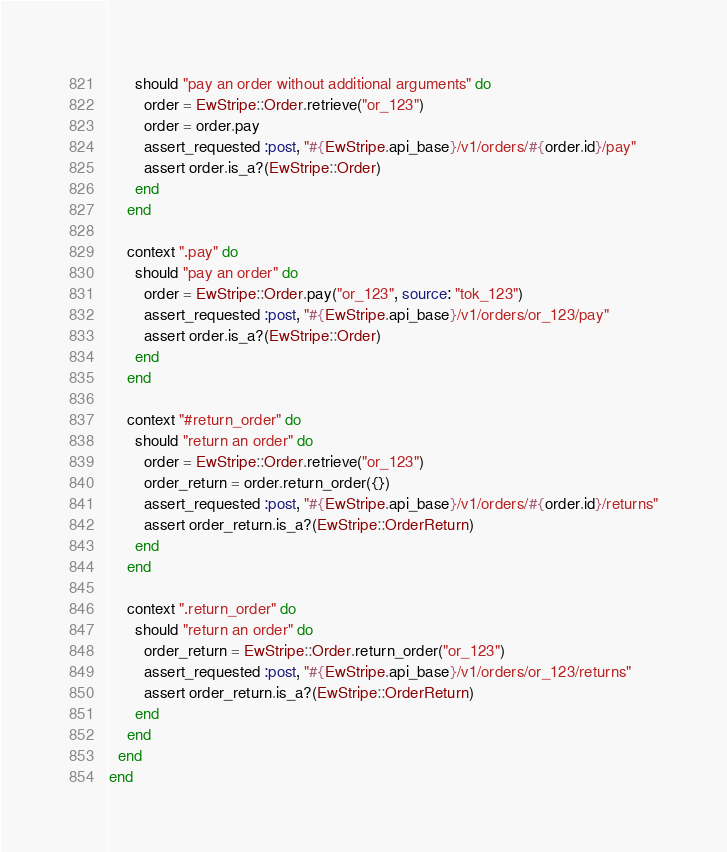<code> <loc_0><loc_0><loc_500><loc_500><_Ruby_>      should "pay an order without additional arguments" do
        order = EwStripe::Order.retrieve("or_123")
        order = order.pay
        assert_requested :post, "#{EwStripe.api_base}/v1/orders/#{order.id}/pay"
        assert order.is_a?(EwStripe::Order)
      end
    end

    context ".pay" do
      should "pay an order" do
        order = EwStripe::Order.pay("or_123", source: "tok_123")
        assert_requested :post, "#{EwStripe.api_base}/v1/orders/or_123/pay"
        assert order.is_a?(EwStripe::Order)
      end
    end

    context "#return_order" do
      should "return an order" do
        order = EwStripe::Order.retrieve("or_123")
        order_return = order.return_order({})
        assert_requested :post, "#{EwStripe.api_base}/v1/orders/#{order.id}/returns"
        assert order_return.is_a?(EwStripe::OrderReturn)
      end
    end

    context ".return_order" do
      should "return an order" do
        order_return = EwStripe::Order.return_order("or_123")
        assert_requested :post, "#{EwStripe.api_base}/v1/orders/or_123/returns"
        assert order_return.is_a?(EwStripe::OrderReturn)
      end
    end
  end
end
</code> 